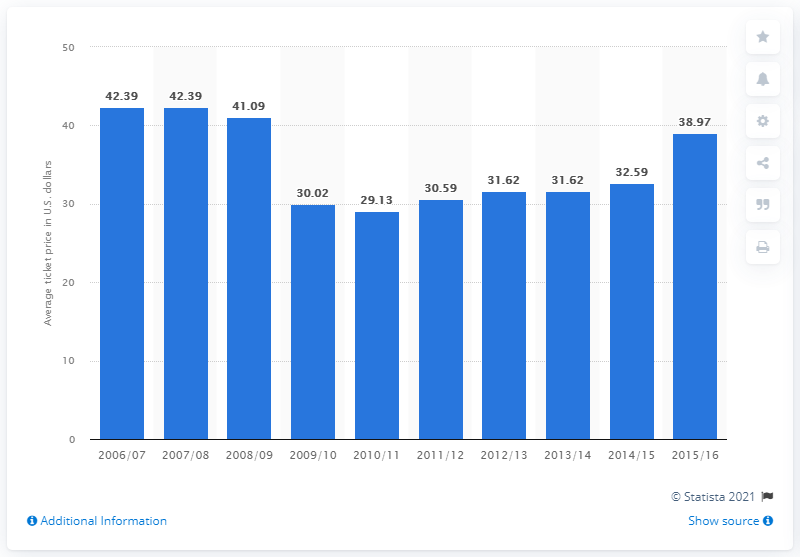Draw attention to some important aspects in this diagram. In the Indiana Pacers' 2006/2007 season, the average ticket price was 42.39 U.S. dollars. 